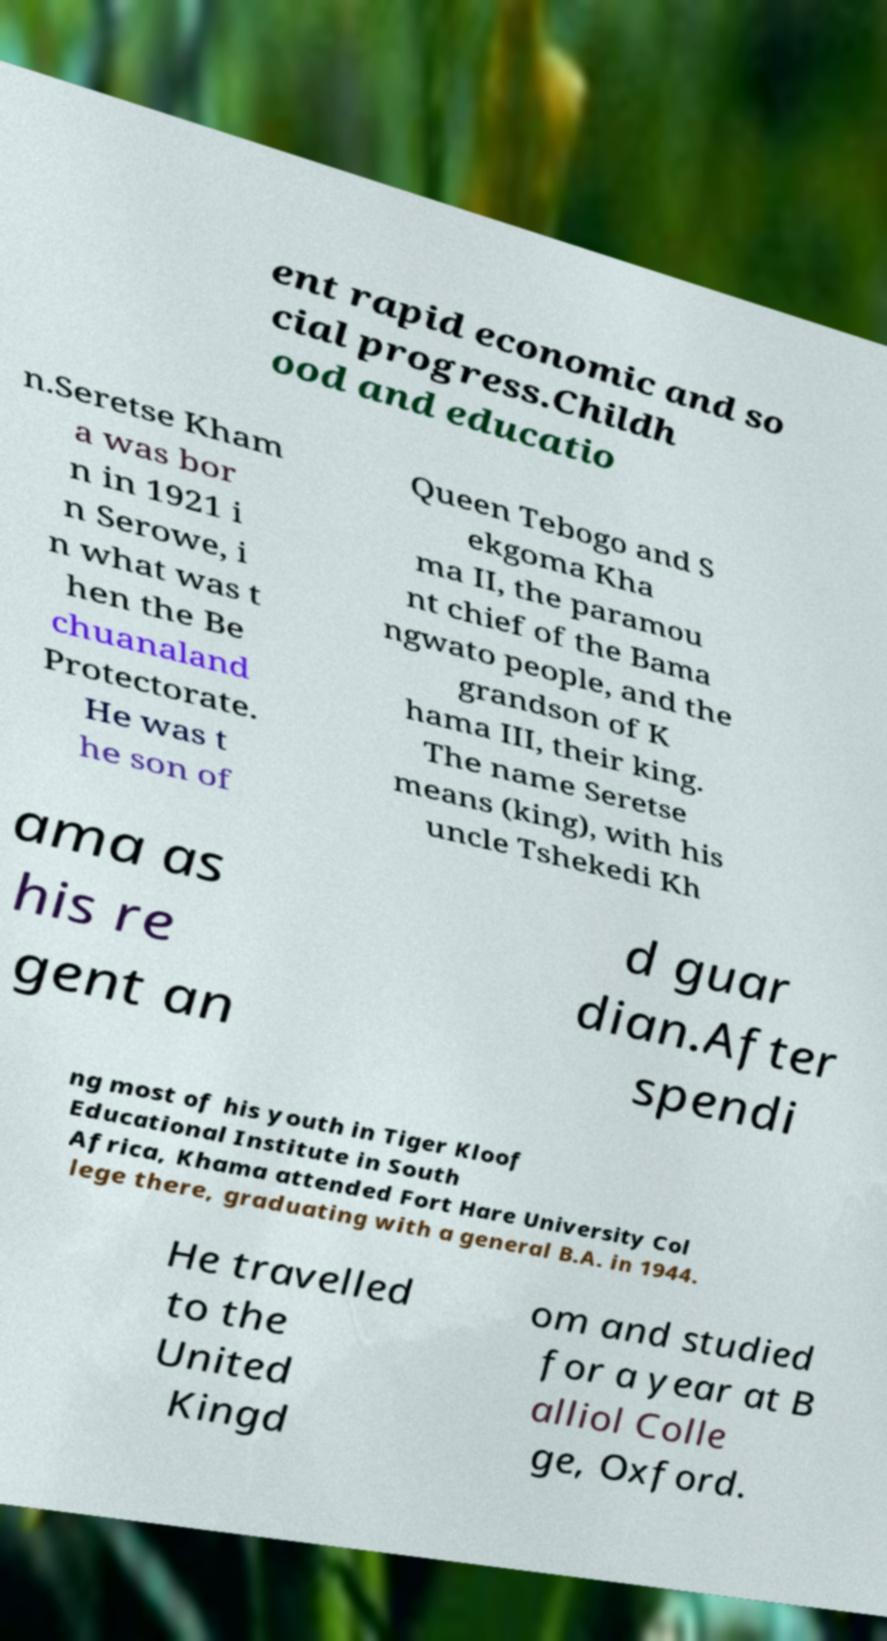I need the written content from this picture converted into text. Can you do that? ent rapid economic and so cial progress.Childh ood and educatio n.Seretse Kham a was bor n in 1921 i n Serowe, i n what was t hen the Be chuanaland Protectorate. He was t he son of Queen Tebogo and S ekgoma Kha ma II, the paramou nt chief of the Bama ngwato people, and the grandson of K hama III, their king. The name Seretse means (king), with his uncle Tshekedi Kh ama as his re gent an d guar dian.After spendi ng most of his youth in Tiger Kloof Educational Institute in South Africa, Khama attended Fort Hare University Col lege there, graduating with a general B.A. in 1944. He travelled to the United Kingd om and studied for a year at B alliol Colle ge, Oxford. 